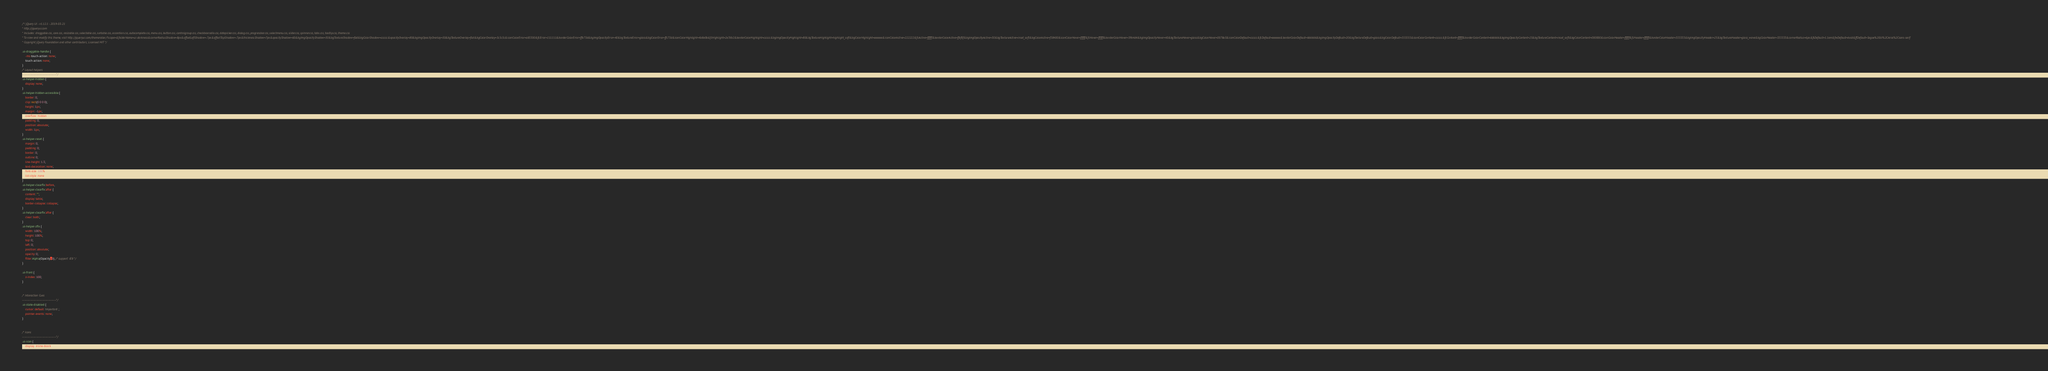<code> <loc_0><loc_0><loc_500><loc_500><_CSS_>/*! jQuery UI - v1.12.1 - 2019-03-21
* http://jqueryui.com
* Includes: draggable.css, core.css, resizable.css, selectable.css, sortable.css, accordion.css, autocomplete.css, menu.css, button.css, controlgroup.css, checkboxradio.css, datepicker.css, dialog.css, progressbar.css, selectmenu.css, slider.css, spinner.css, tabs.css, tooltip.css, theme.css
* To view and modify this theme, visit http://jqueryui.com/themeroller/?scope=&folderName=ui-darkness&cornerRadiusShadow=8px&offsetLeftShadow=-7px&offsetTopShadow=-7px&thicknessShadow=7px&opacityShadow=60&bgImgOpacityShadow=30&bgTextureShadow=flat&bgColorShadow=cccccc&opacityOverlay=80&bgImgOpacityOverlay=50&bgTextureOverlay=flat&bgColorOverlay=5c5c5c&iconColorError=a83300&fcError=111111&borderColorError=ffb73d&bgImgOpacityError=40&bgTextureError=glass&bgColorError=ffc73d&iconColorHighlight=4b8e0b&fcHighlight=2e7db2&borderColorHighlight=cccccc&bgImgOpacityHighlight=80&bgTextureHighlight=highlight_soft&bgColorHighlight=eeeeee&iconColorActive=222222&fcActive=ffffff&borderColorActive=ffaf0f&bgImgOpacityActive=30&bgTextureActive=inset_soft&bgColorActive=f58400&iconColorHover=ffffff&fcHover=ffffff&borderColorHover=59b4d4&bgImgOpacityHover=40&bgTextureHover=glass&bgColorHover=0078a3&iconColorDefault=cccccc&fcDefault=eeeeee&borderColorDefault=666666&bgImgOpacityDefault=20&bgTextureDefault=glass&bgColorDefault=555555&iconColorContent=cccccc&fcContent=ffffff&borderColorContent=666666&bgImgOpacityContent=25&bgTextureContent=inset_soft&bgColorContent=000000&iconColorHeader=ffffff&fcHeader=ffffff&borderColorHeader=333333&bgImgOpacityHeader=25&bgTextureHeader=gloss_wave&bgColorHeader=333333&cornerRadius=6px&fsDefault=1.1em&fwDefault=bold&ffDefault=Segoe%20UI%2CArial%2Csans-serif
* Copyright jQuery Foundation and other contributors; Licensed MIT */

.ui-draggable-handle {
	-ms-touch-action: none;
	touch-action: none;
}
/* Layout helpers
----------------------------------*/
.ui-helper-hidden {
	display: none;
}
.ui-helper-hidden-accessible {
	border: 0;
	clip: rect(0 0 0 0);
	height: 1px;
	margin: -1px;
	overflow: hidden;
	padding: 0;
	position: absolute;
	width: 1px;
}
.ui-helper-reset {
	margin: 0;
	padding: 0;
	border: 0;
	outline: 0;
	line-height: 1.3;
	text-decoration: none;
	font-size: 100%;
	list-style: none;
}
.ui-helper-clearfix:before,
.ui-helper-clearfix:after {
	content: "";
	display: table;
	border-collapse: collapse;
}
.ui-helper-clearfix:after {
	clear: both;
}
.ui-helper-zfix {
	width: 100%;
	height: 100%;
	top: 0;
	left: 0;
	position: absolute;
	opacity: 0;
	filter:Alpha(Opacity=0); /* support: IE8 */
}

.ui-front {
	z-index: 100;
}


/* Interaction Cues
----------------------------------*/
.ui-state-disabled {
	cursor: default !important;
	pointer-events: none;
}


/* Icons
----------------------------------*/
.ui-icon {
	display: inline-block;</code> 